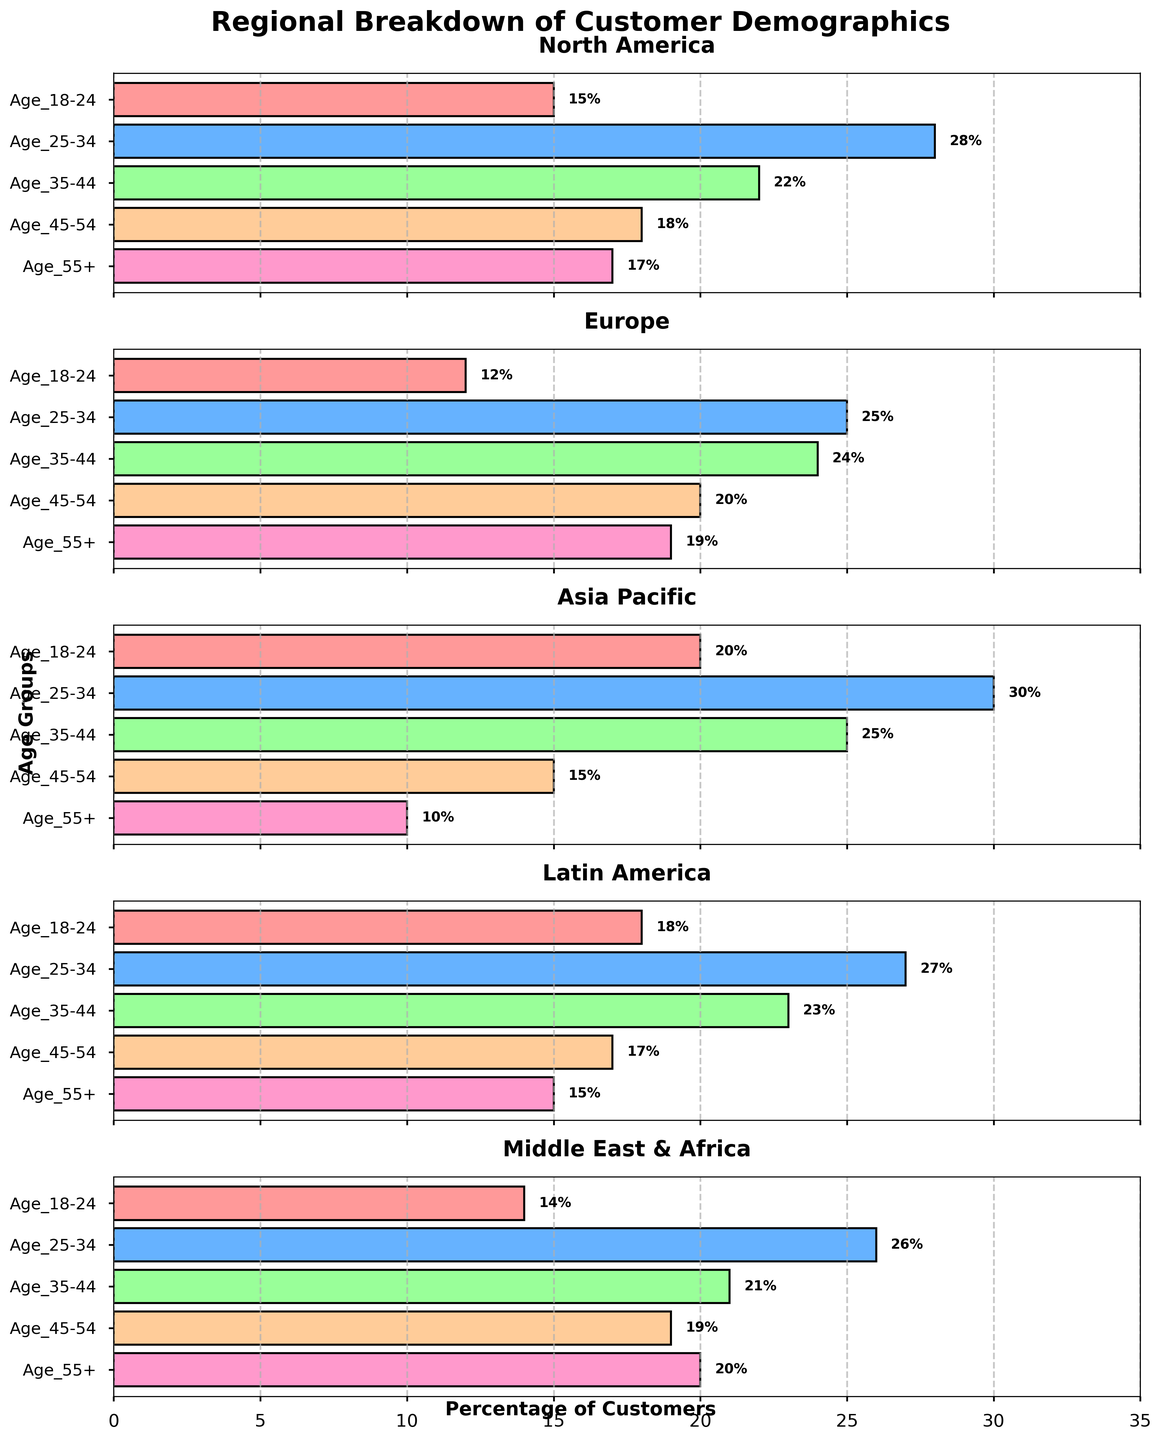What is the title of the figure? The title is displayed at the top of the figure, and it reads "Regional Breakdown of Customer Demographics".
Answer: Regional Breakdown of Customer Demographics What age group has the highest percentage in North America? Looking at the bar lengths in the North America subplot, the longest bar corresponds to the age group 25-34 with a value of 28%.
Answer: Age 25-34 Which region has the smallest percentage of customers aged 55+? By inspecting the bar lengths for the age group 55+ across all subplots, the shortest bar is in the Asia Pacific region with a value of 10%.
Answer: Asia Pacific What is the total percentage of customers aged 25-34 and 35-44 in Europe? In the Europe subplot, the percentages for age groups 25-34 and 35-44 are 25% and 24%, respectively. Summing these gives 25% + 24% = 49%.
Answer: 49% How does the percentage of customers aged 18-24 in Latin America compare to those in the Middle East & Africa? In the Latin America subplot, the value for age 18-24 is 18%. In the Middle East & Africa subplot, it's 14%. Comparing these, 18% is greater than 14%.
Answer: Latin America has a higher percentage Which age group is consistently present in all regions but never has the highest percentage in any region? By examining all subplots, the age group 55+ is present in all regions but does not have the highest value in any of them.
Answer: Age 55+ What is the range of the percentages for the age group 35-44 across all regions? The percentages for age group 35-44 in each region are: North America (22%), Europe (24%), Asia Pacific (25%), Latin America (23%), Middle East & Africa (21%). The range is found by subtracting the minimum value (21%) from the maximum value (25%), resulting in 25% - 21% = 4%.
Answer: 4% Which region has the most evenly distributed age group percentages? "Evenly distributed" implies the values are close to each other. In the subplots, Europe has percentages 12%, 25%, 24%, 20%, 19%, which appear more balanced compared to other regions.
Answer: Europe What is the average percentage of customers aged 18-24 across all regions? Adding the percentages for age group 18-24 from all regions (15% + 12% + 20% + 18% + 14%) gives 79%. There are 5 regions, so 79% / 5 = 15.8%.
Answer: 15.8% 